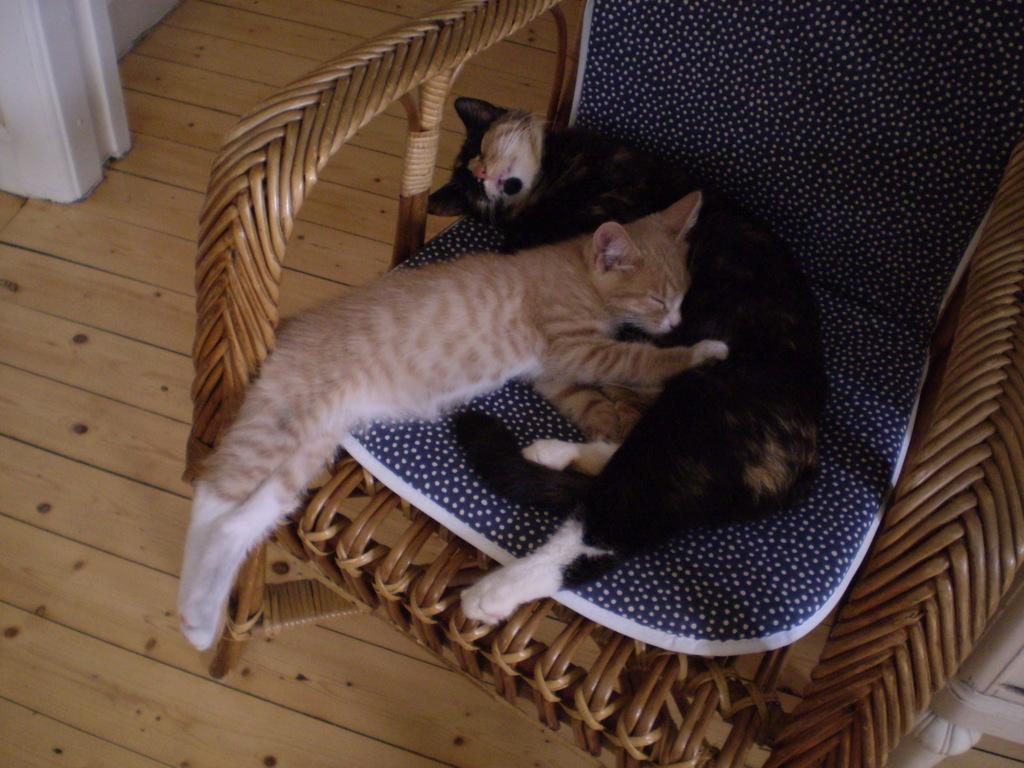Please provide a concise description of this image. In this image there is a chair and we can see a cushion placed on the chair. There are cats on the chair. In the background there is a floor. 